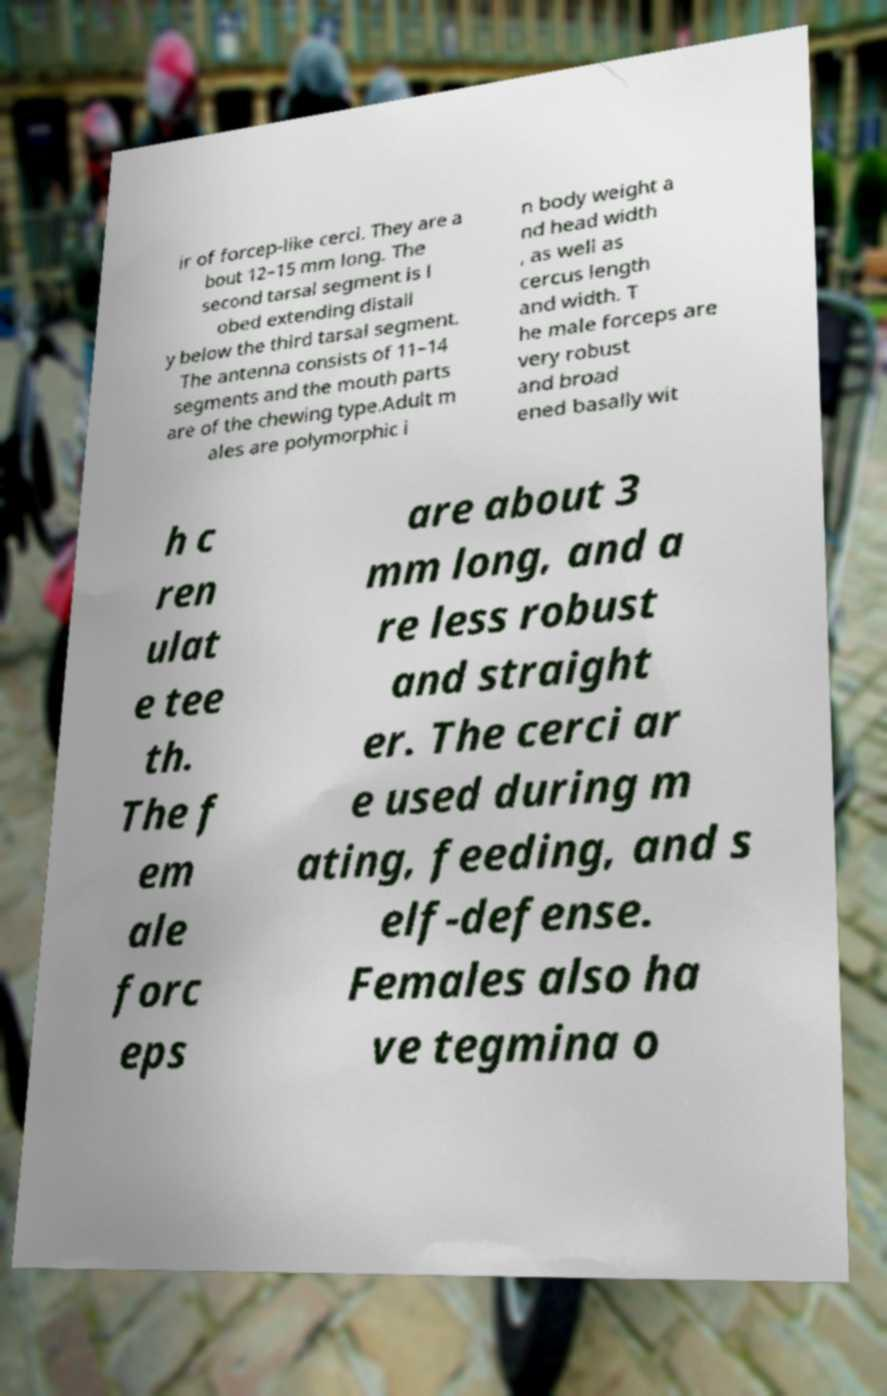Could you extract and type out the text from this image? ir of forcep-like cerci. They are a bout 12–15 mm long. The second tarsal segment is l obed extending distall y below the third tarsal segment. The antenna consists of 11–14 segments and the mouth parts are of the chewing type.Adult m ales are polymorphic i n body weight a nd head width , as well as cercus length and width. T he male forceps are very robust and broad ened basally wit h c ren ulat e tee th. The f em ale forc eps are about 3 mm long, and a re less robust and straight er. The cerci ar e used during m ating, feeding, and s elf-defense. Females also ha ve tegmina o 